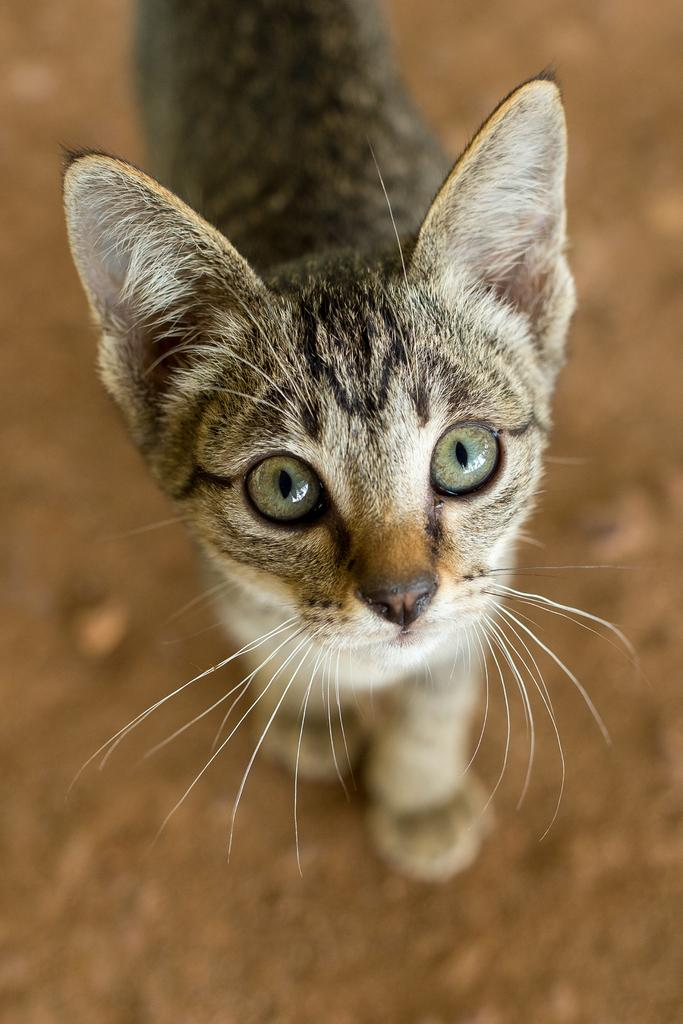What type of animal is in the picture? There is a cat in the picture. What is the cat doing in the image? The cat is standing. What color is the floor in the image? The floor in the image is brown-colored. What type of protest is the cat participating in within the image? There is no protest present in the image; it features a cat standing on a brown-colored floor. What is the range of the cat's flesh in the image? The image does not provide information about the cat's flesh or its range, as it only shows the cat standing on a brown-colored floor. 